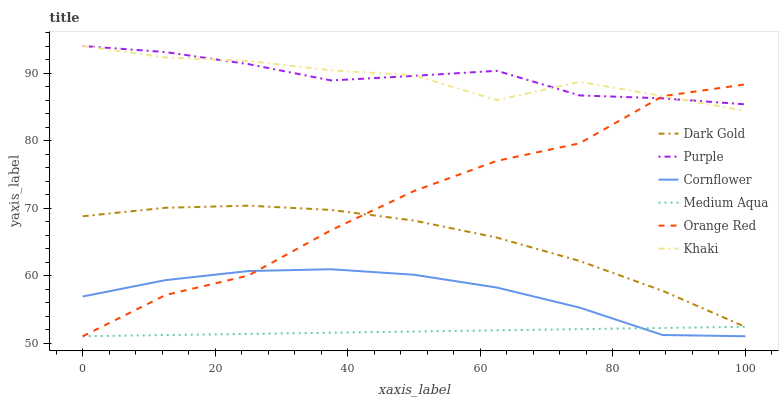Does Khaki have the minimum area under the curve?
Answer yes or no. No. Does Khaki have the maximum area under the curve?
Answer yes or no. No. Is Khaki the smoothest?
Answer yes or no. No. Is Khaki the roughest?
Answer yes or no. No. Does Khaki have the lowest value?
Answer yes or no. No. Does Dark Gold have the highest value?
Answer yes or no. No. Is Cornflower less than Dark Gold?
Answer yes or no. Yes. Is Khaki greater than Cornflower?
Answer yes or no. Yes. Does Cornflower intersect Dark Gold?
Answer yes or no. No. 